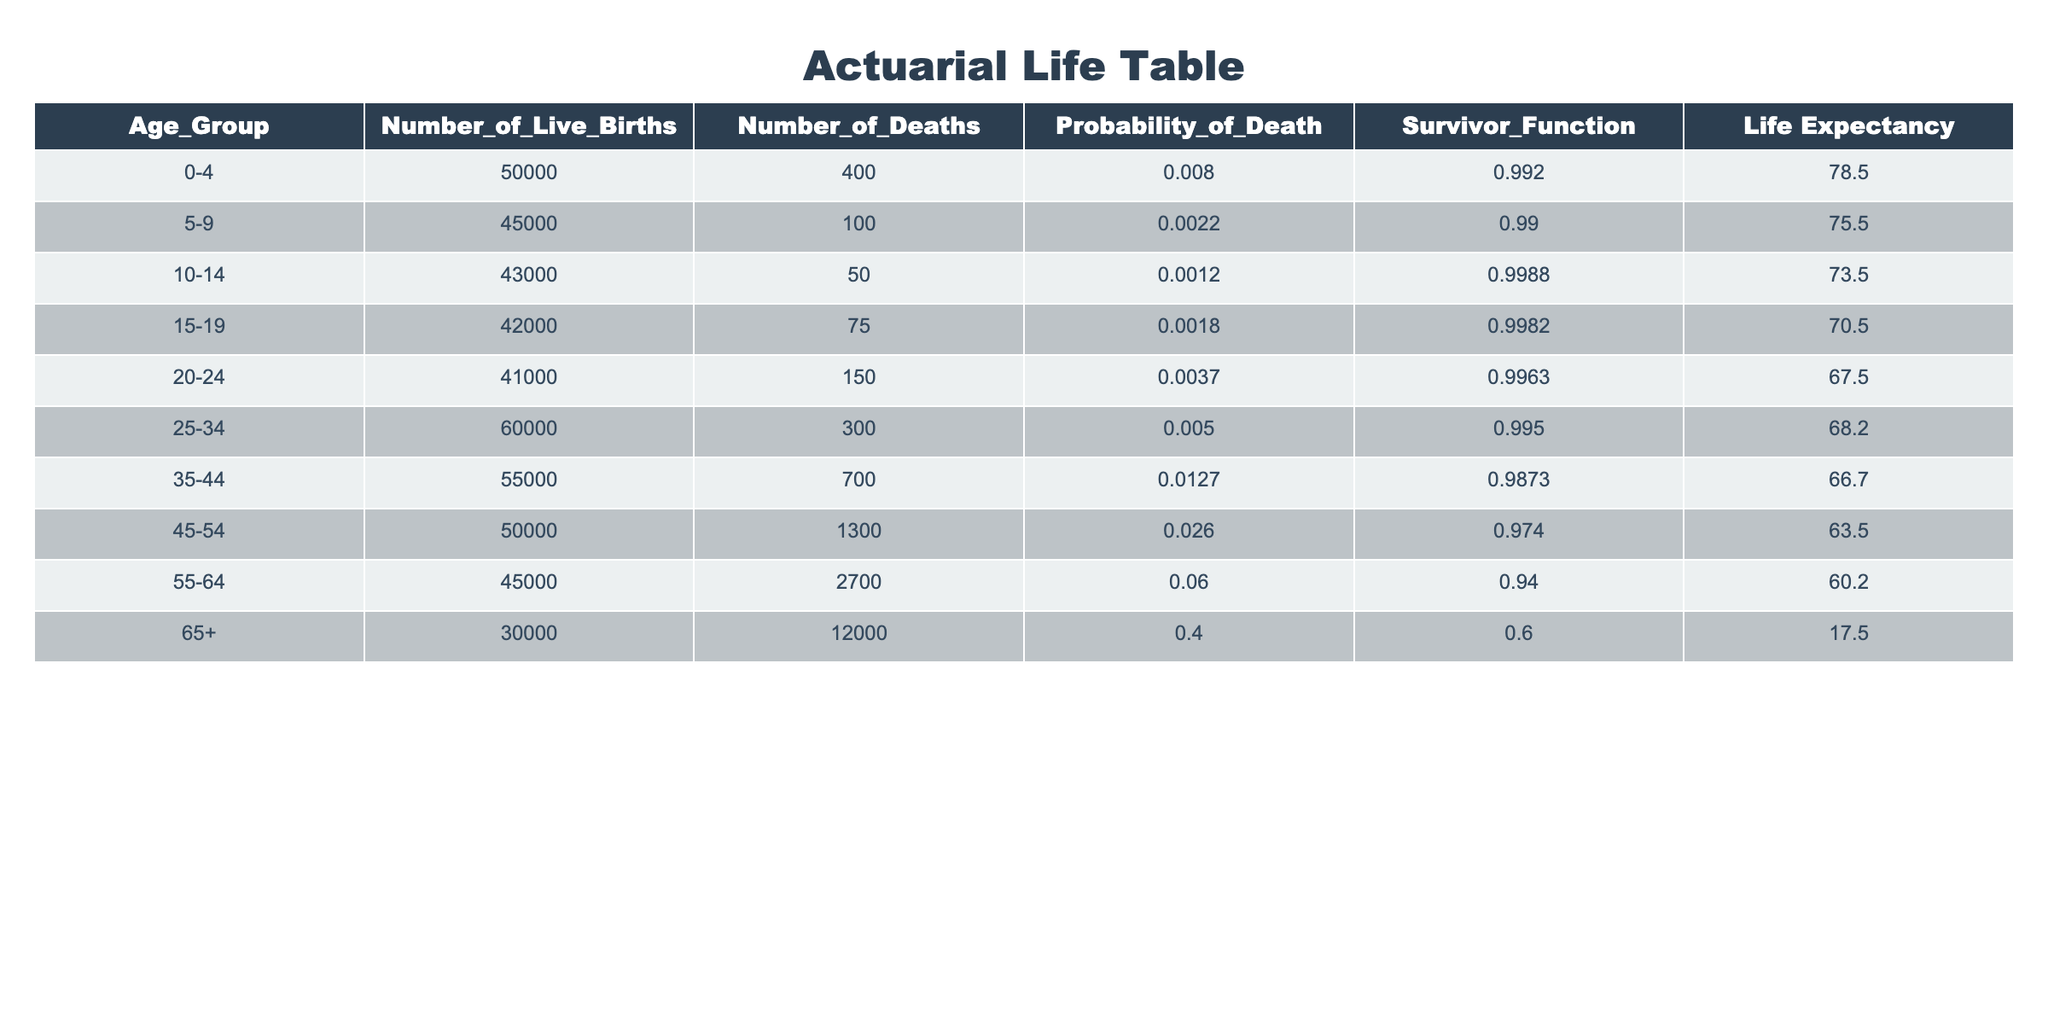What is the probability of death for the age group 55-64? The table lists the probability of death for each age group. For the age group 55-64, the probability of death is given directly as 0.06.
Answer: 0.06 How many deaths occurred in the age group 45-54? The table shows the number of deaths in each age group. For the age group 45-54, the number of deaths is stated as 1300.
Answer: 1300 What is the total number of live births for age groups 0-4 and 5-9 combined? To find the total number of live births for these two age groups, we add their individual numbers: 50000 (for age 0-4) + 45000 (for age 5-9) = 95000.
Answer: 95000 Which age group has the highest number of deaths? By examining the “Number_of_Deaths” column, the age group 65+ has the highest number with 12000 deaths, which is greater than any other age group listed.
Answer: 65+ Is the probability of death higher in the age group 35-44 compared to the age group 25-34? For the age group 35-44, the probability of death is 0.0127, while for 25-34, it is 0.005. Since 0.0127 is greater than 0.005, the answer is yes.
Answer: Yes What is the average life expectancy for age groups 20-24, 25-34, and 35-44? The life expectancy values for these groups are: 67.5 (for 20-24), 68.2 (for 25-34), and 66.7 (for 35-44). Summing these gives 67.5 + 68.2 + 66.7 = 202.4. Dividing by 3 gives an average life expectancy of 202.4 / 3 = 67.47.
Answer: 67.47 Does the probability of death increase as age groups progress from 0-4 to 65+? A quick glance at the "Probability_of_Death" column shows that the values increase as the age groups advance. The probability starts at 0.008 for 0-4 and rises to 0.4 for 65+, confirming that it does increase.
Answer: Yes What is the difference in life expectancy between age group 55-64 and 65+? The life expectancy for age group 55-64 is 60.2 and for 65+ it is 17.5. To find the difference, we subtract: 60.2 - 17.5 = 42.7.
Answer: 42.7 